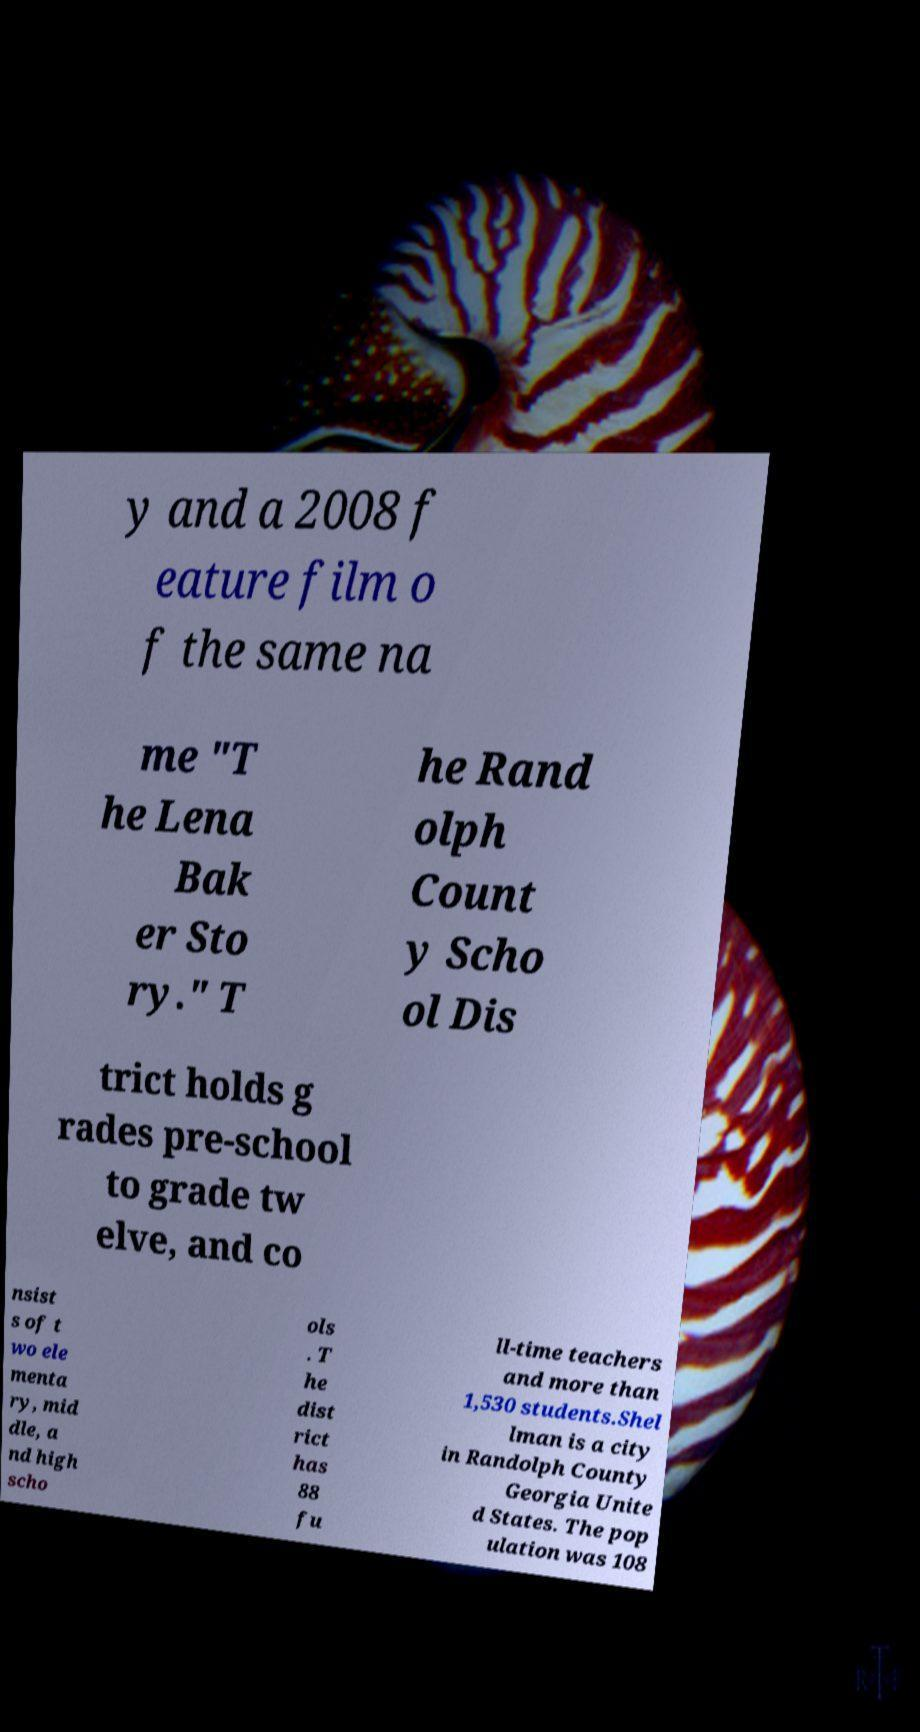For documentation purposes, I need the text within this image transcribed. Could you provide that? y and a 2008 f eature film o f the same na me "T he Lena Bak er Sto ry." T he Rand olph Count y Scho ol Dis trict holds g rades pre-school to grade tw elve, and co nsist s of t wo ele menta ry, mid dle, a nd high scho ols . T he dist rict has 88 fu ll-time teachers and more than 1,530 students.Shel lman is a city in Randolph County Georgia Unite d States. The pop ulation was 108 